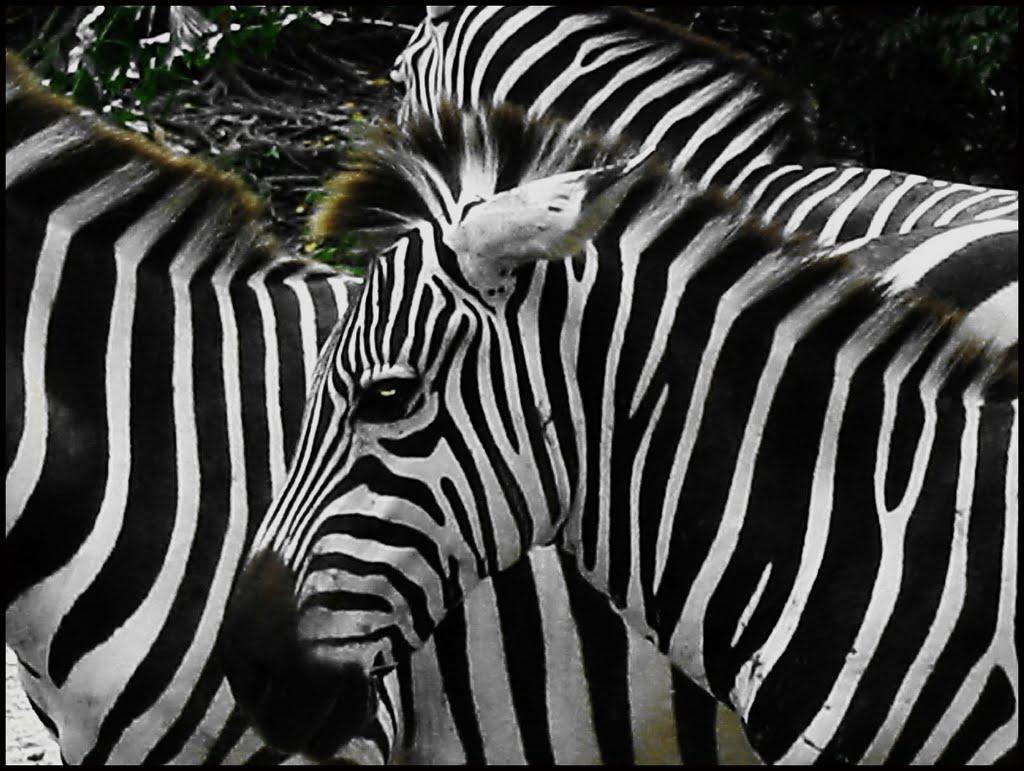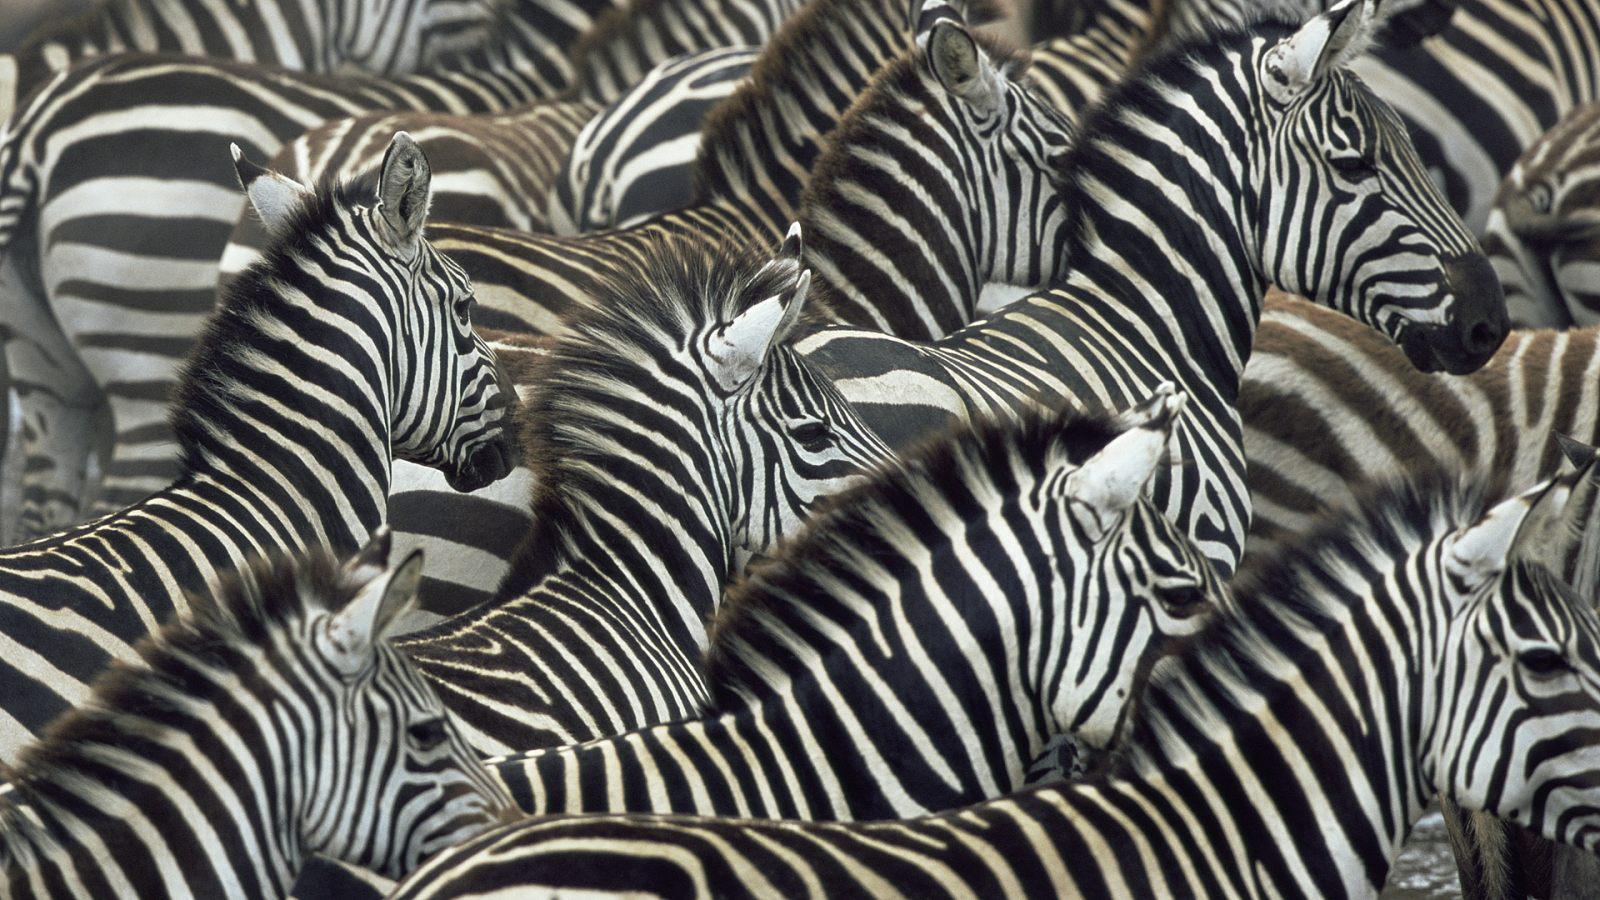The first image is the image on the left, the second image is the image on the right. Given the left and right images, does the statement "One image shows a mass of rightward-facing zebras with no space visible between any of them." hold true? Answer yes or no. Yes. 